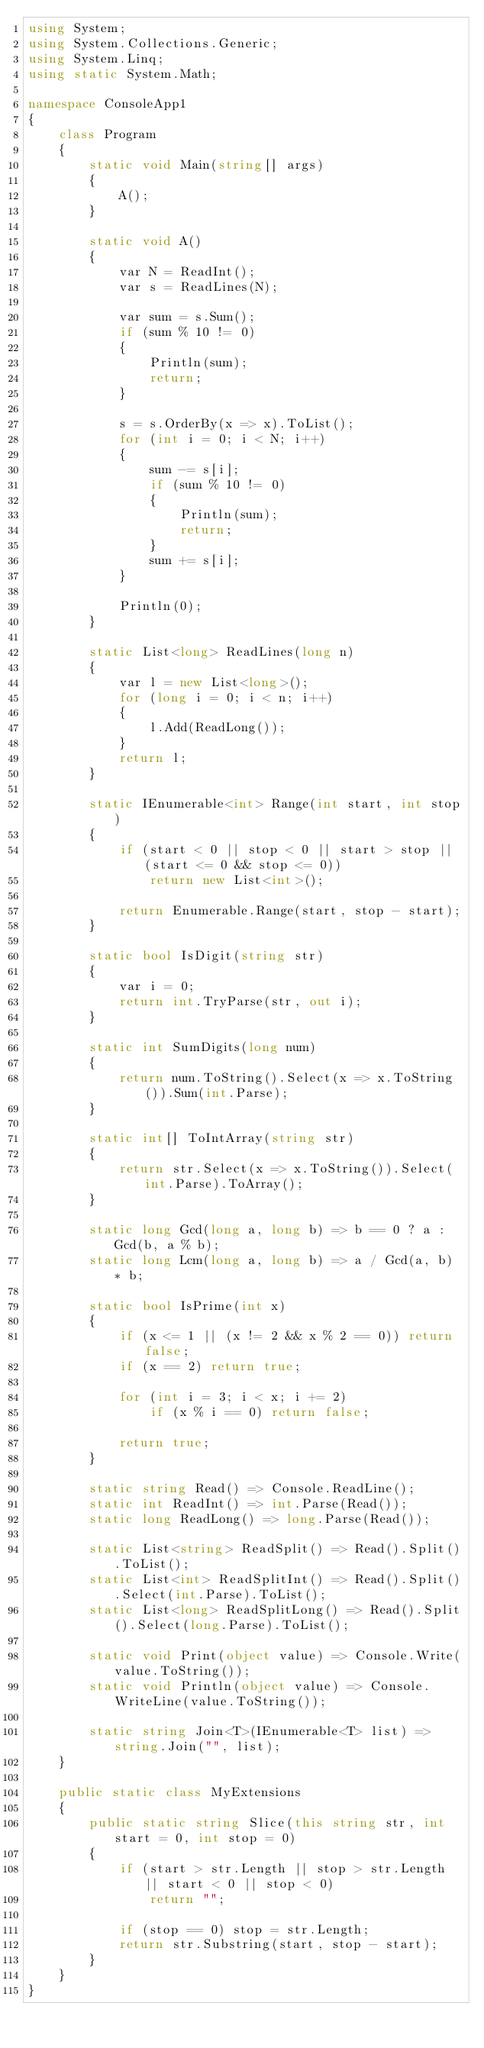<code> <loc_0><loc_0><loc_500><loc_500><_C#_>using System;
using System.Collections.Generic;
using System.Linq;
using static System.Math;

namespace ConsoleApp1
{
    class Program
    {
        static void Main(string[] args)
        {
            A();
        }

        static void A()
        {
            var N = ReadInt();
            var s = ReadLines(N);

            var sum = s.Sum();
            if (sum % 10 != 0)
            {
                Println(sum);
                return;
            }

            s = s.OrderBy(x => x).ToList();
            for (int i = 0; i < N; i++)
            {
                sum -= s[i];
                if (sum % 10 != 0)
                {
                    Println(sum);
                    return;
                }
                sum += s[i];
            }

            Println(0);
        }

        static List<long> ReadLines(long n)
        {
            var l = new List<long>();
            for (long i = 0; i < n; i++)
            {
                l.Add(ReadLong());
            }
            return l;
        }

        static IEnumerable<int> Range(int start, int stop)
        {
            if (start < 0 || stop < 0 || start > stop || (start <= 0 && stop <= 0))
                return new List<int>();

            return Enumerable.Range(start, stop - start);
        }

        static bool IsDigit(string str)
        {
            var i = 0;
            return int.TryParse(str, out i);
        }

        static int SumDigits(long num)
        {
            return num.ToString().Select(x => x.ToString()).Sum(int.Parse);
        }

        static int[] ToIntArray(string str)
        {
            return str.Select(x => x.ToString()).Select(int.Parse).ToArray();
        }

        static long Gcd(long a, long b) => b == 0 ? a : Gcd(b, a % b);
        static long Lcm(long a, long b) => a / Gcd(a, b) * b;

        static bool IsPrime(int x)
        {
            if (x <= 1 || (x != 2 && x % 2 == 0)) return false;
            if (x == 2) return true;

            for (int i = 3; i < x; i += 2)
                if (x % i == 0) return false;

            return true;
        }

        static string Read() => Console.ReadLine();
        static int ReadInt() => int.Parse(Read());
        static long ReadLong() => long.Parse(Read());

        static List<string> ReadSplit() => Read().Split().ToList();
        static List<int> ReadSplitInt() => Read().Split().Select(int.Parse).ToList();
        static List<long> ReadSplitLong() => Read().Split().Select(long.Parse).ToList();

        static void Print(object value) => Console.Write(value.ToString());
        static void Println(object value) => Console.WriteLine(value.ToString());

        static string Join<T>(IEnumerable<T> list) => string.Join("", list);
    }

    public static class MyExtensions
    {
        public static string Slice(this string str, int start = 0, int stop = 0)
        {
            if (start > str.Length || stop > str.Length || start < 0 || stop < 0)
                return "";

            if (stop == 0) stop = str.Length;
            return str.Substring(start, stop - start);
        }
    }
}</code> 